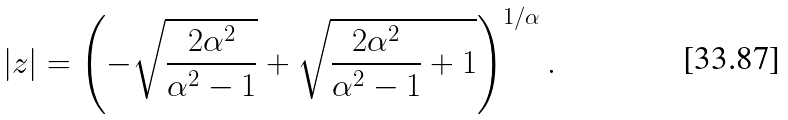Convert formula to latex. <formula><loc_0><loc_0><loc_500><loc_500>| z | = \left ( - \sqrt { \frac { 2 \alpha ^ { 2 } } { \alpha ^ { 2 } - 1 } } + \sqrt { \frac { 2 \alpha ^ { 2 } } { \alpha ^ { 2 } - 1 } + 1 } \right ) ^ { 1 / \alpha } .</formula> 